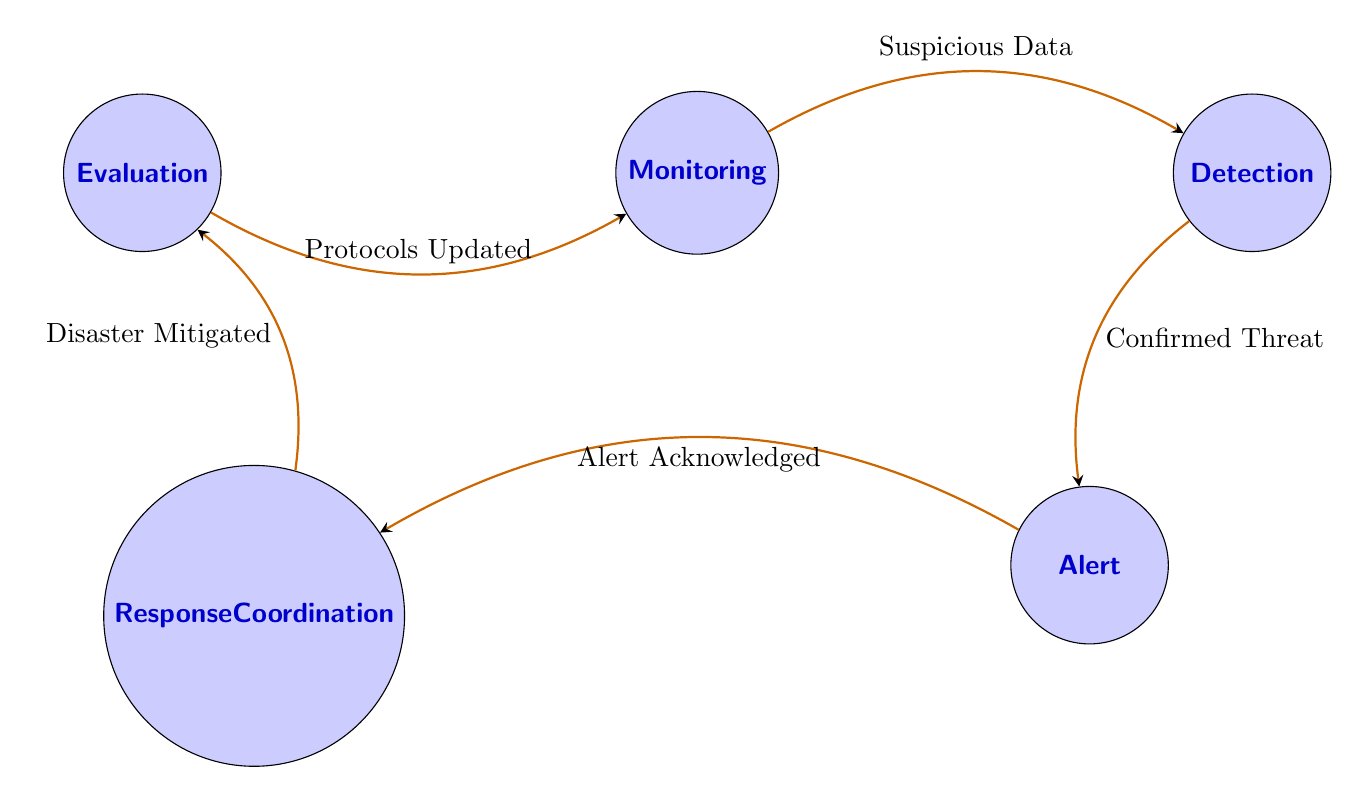What are the names of all the states in the diagram? The diagram features five states: Monitoring, Detection, Alert, Response Coordination, and Evaluation.
Answer: Monitoring, Detection, Alert, Response Coordination, Evaluation How many transitions are present in the diagram? There are five transitions connecting the states: from Monitoring to Detection, Detection to Alert, Alert to Response Coordination, Response Coordination to Evaluation, and Evaluation back to Monitoring.
Answer: Five What is the trigger that leads from Detection to Alert? The transition from Detection to Alert is triggered by a "Confirmed Threat." This implies that an identified event has been verified as an actual natural disaster threat.
Answer: Confirmed Threat What action is associated with the Evaluation state? The Evaluation state is associated with two actions: "Review Actions" and "Update Protocols," which focus on assessing the response and improving future protocols.
Answer: Review Actions, Update Protocols Which state comes after Alert in the diagram? The state that follows Alert in the diagram is Response Coordination, indicating that once an alert is acknowledged, coordination of emergency services begins.
Answer: Response Coordination What is the initial state in the finite state machine? The initial state in the finite state machine is Monitoring, as it represents the first step where real-time data is collected.
Answer: Monitoring How does the flow return to the Monitoring state? The flow returns to the Monitoring state through the Evaluation state, triggered by "Protocols Updated," indicating that after the evaluation, the system resumes monitoring activities.
Answer: Protocols Updated What kind of data patterns trigger the transition from Monitoring to Detection? A "Suspicious Data Pattern" triggers the transition from Monitoring to Detection, indicating that unusual patterns have been identified that require further investigation.
Answer: Suspicious Data Pattern What primarily occurs during the Response Coordination state? During the Response Coordination state, the primary actions taken include "Deploy Services" and "Coordinate Efforts" to efficiently manage emergency responses among relevant agencies.
Answer: Deploy Services, Coordinate Efforts 